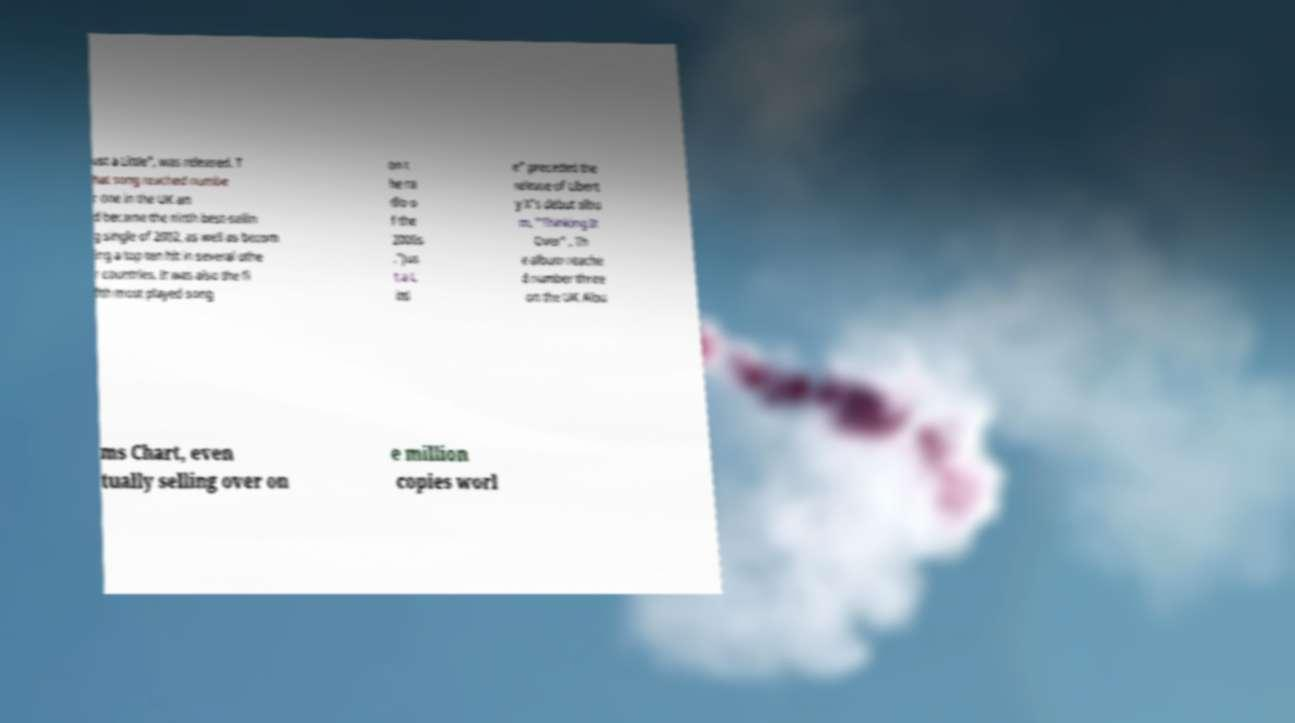For documentation purposes, I need the text within this image transcribed. Could you provide that? ust a Little", was released. T hat song reached numbe r one in the UK an d became the ninth best-sellin g single of 2002, as well as becom ing a top ten hit in several othe r countries. It was also the fi fth most played song on t he ra dio o f the 2000s ."Jus t a L ittl e" preceded the release of Libert y X's debut albu m, "Thinking It Over" . Th e album reache d number three on the UK Albu ms Chart, even tually selling over on e million copies worl 